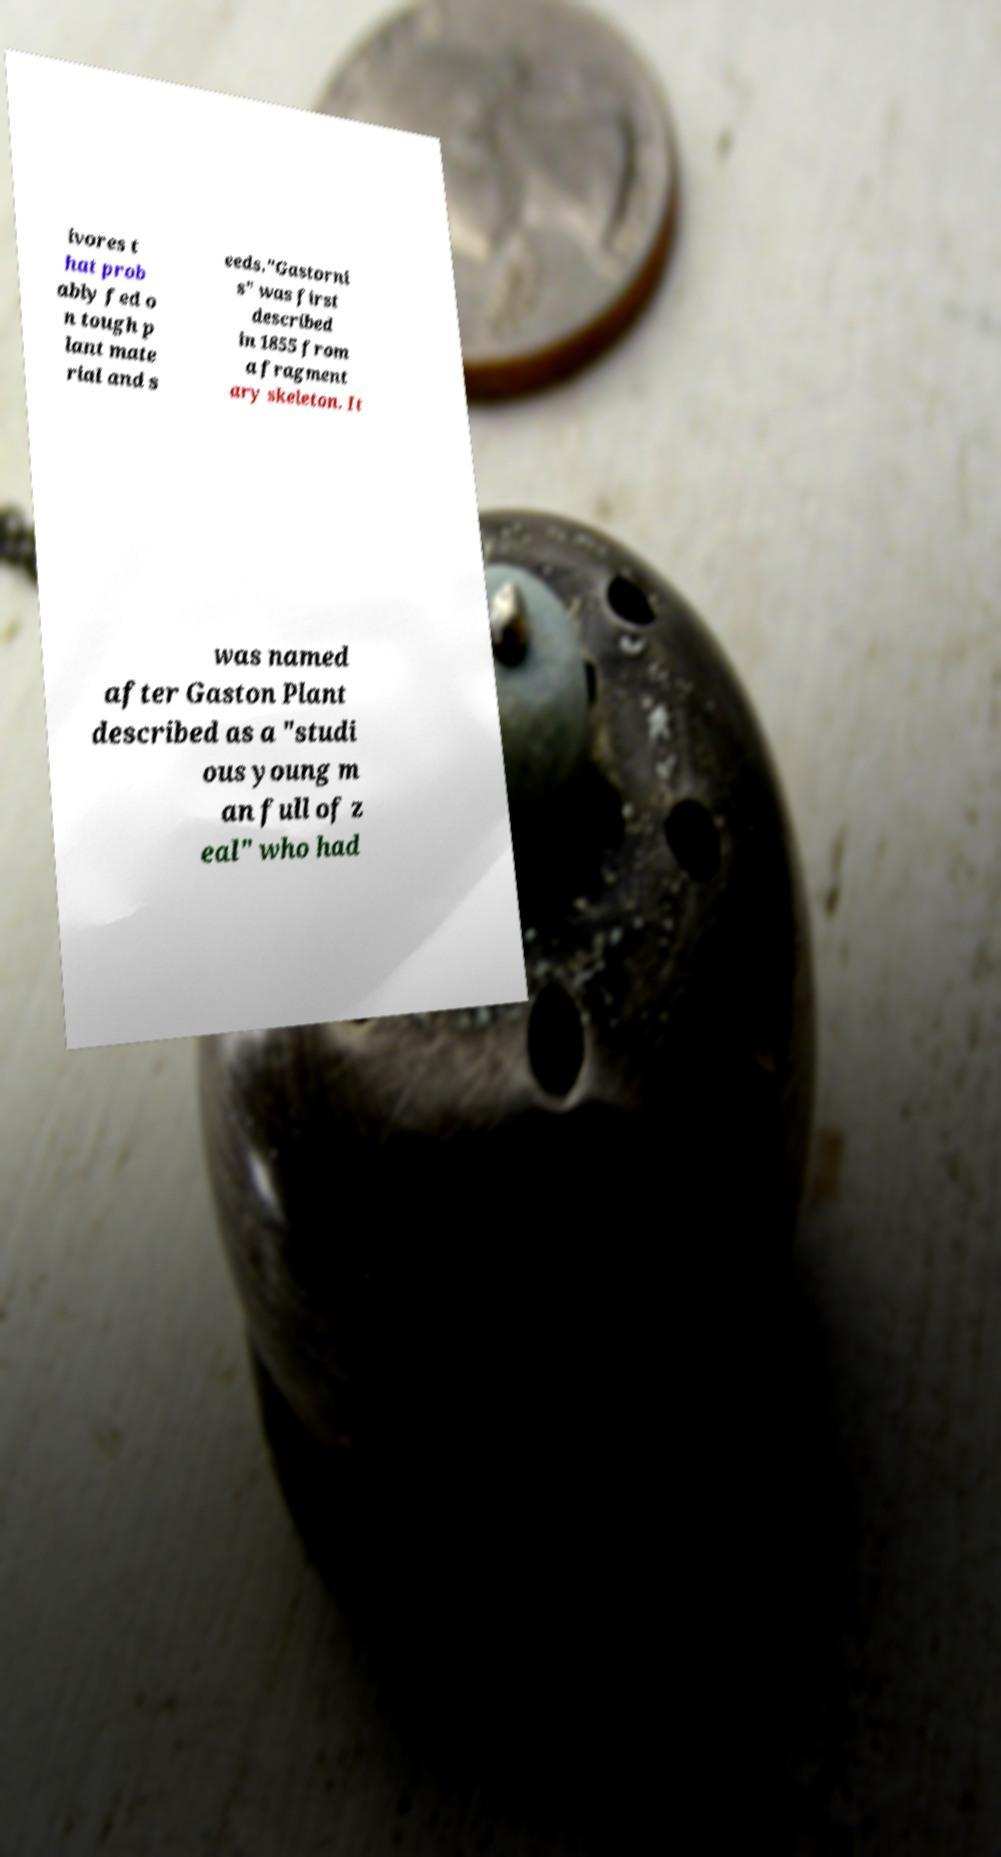What messages or text are displayed in this image? I need them in a readable, typed format. ivores t hat prob ably fed o n tough p lant mate rial and s eeds."Gastorni s" was first described in 1855 from a fragment ary skeleton. It was named after Gaston Plant described as a "studi ous young m an full of z eal" who had 